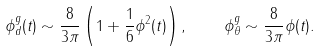Convert formula to latex. <formula><loc_0><loc_0><loc_500><loc_500>\phi _ { d } ^ { g } ( t ) \sim \frac { 8 } { 3 \pi } \left ( 1 + \frac { 1 } { 6 } \phi ^ { 2 } ( t ) \right ) , \quad \phi _ { \theta } ^ { g } \sim \frac { 8 } { 3 \pi } \phi ( t ) .</formula> 